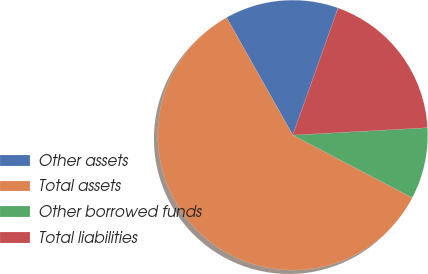<chart> <loc_0><loc_0><loc_500><loc_500><pie_chart><fcel>Other assets<fcel>Total assets<fcel>Other borrowed funds<fcel>Total liabilities<nl><fcel>13.61%<fcel>59.16%<fcel>8.55%<fcel>18.67%<nl></chart> 